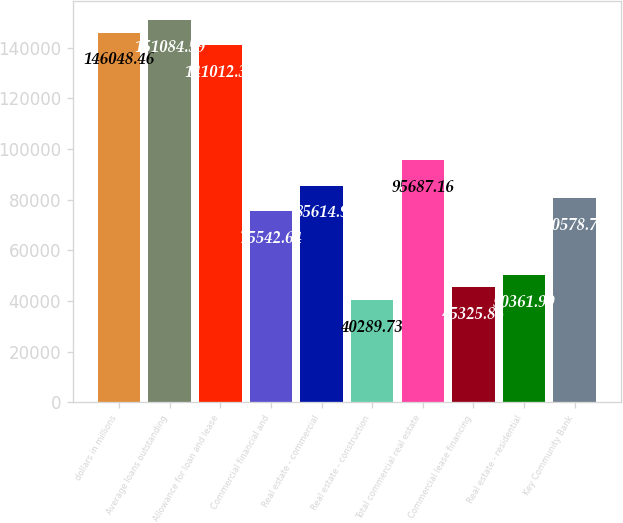Convert chart. <chart><loc_0><loc_0><loc_500><loc_500><bar_chart><fcel>dollars in millions<fcel>Average loans outstanding<fcel>Allowance for loan and lease<fcel>Commercial financial and<fcel>Real estate - commercial<fcel>Real estate - construction<fcel>Total commercial real estate<fcel>Commercial lease financing<fcel>Real estate - residential<fcel>Key Community Bank<nl><fcel>146048<fcel>151085<fcel>141012<fcel>75542.6<fcel>85614.9<fcel>40289.7<fcel>95687.2<fcel>45325.9<fcel>50362<fcel>80578.8<nl></chart> 